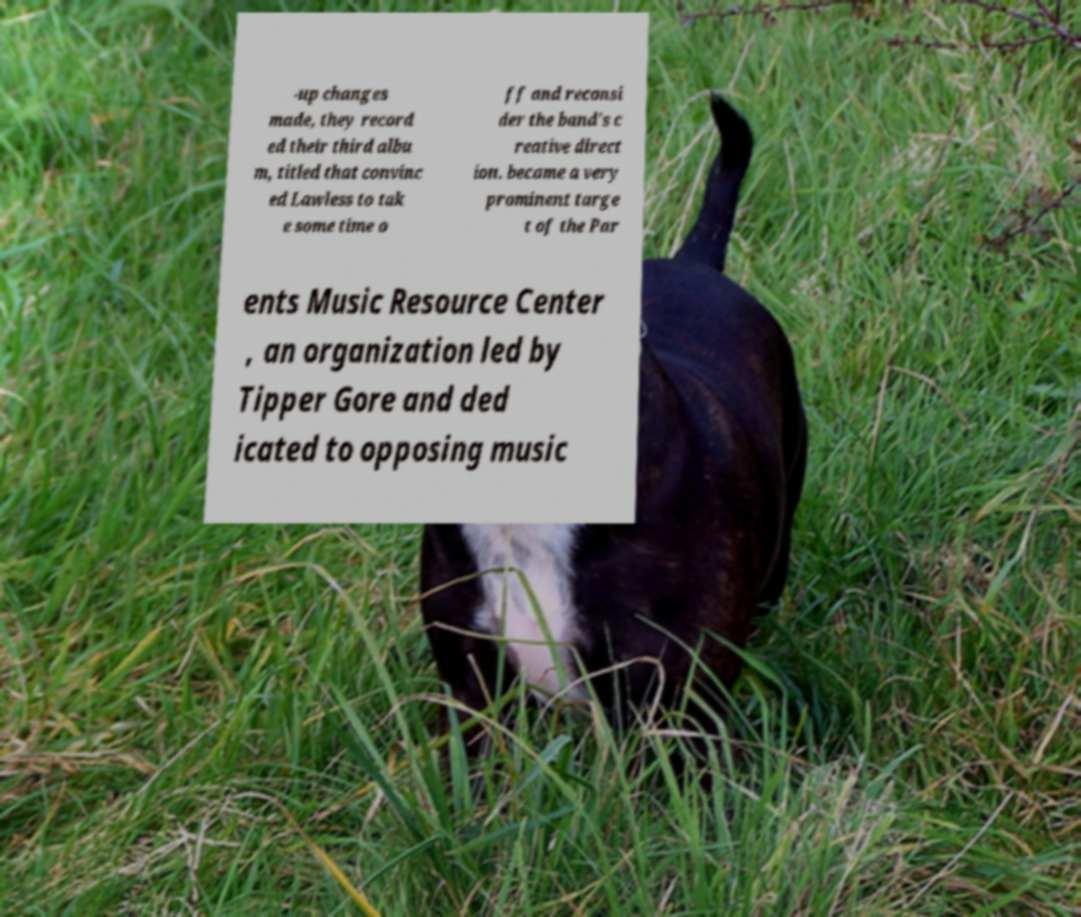There's text embedded in this image that I need extracted. Can you transcribe it verbatim? -up changes made, they record ed their third albu m, titled that convinc ed Lawless to tak e some time o ff and reconsi der the band's c reative direct ion. became a very prominent targe t of the Par ents Music Resource Center , an organization led by Tipper Gore and ded icated to opposing music 